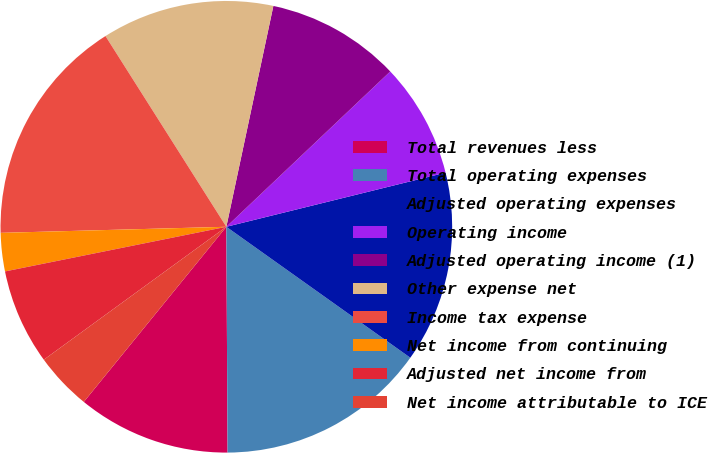Convert chart. <chart><loc_0><loc_0><loc_500><loc_500><pie_chart><fcel>Total revenues less<fcel>Total operating expenses<fcel>Adjusted operating expenses<fcel>Operating income<fcel>Adjusted operating income (1)<fcel>Other expense net<fcel>Income tax expense<fcel>Net income from continuing<fcel>Adjusted net income from<fcel>Net income attributable to ICE<nl><fcel>10.96%<fcel>15.07%<fcel>13.7%<fcel>8.22%<fcel>9.59%<fcel>12.33%<fcel>16.44%<fcel>2.74%<fcel>6.85%<fcel>4.11%<nl></chart> 